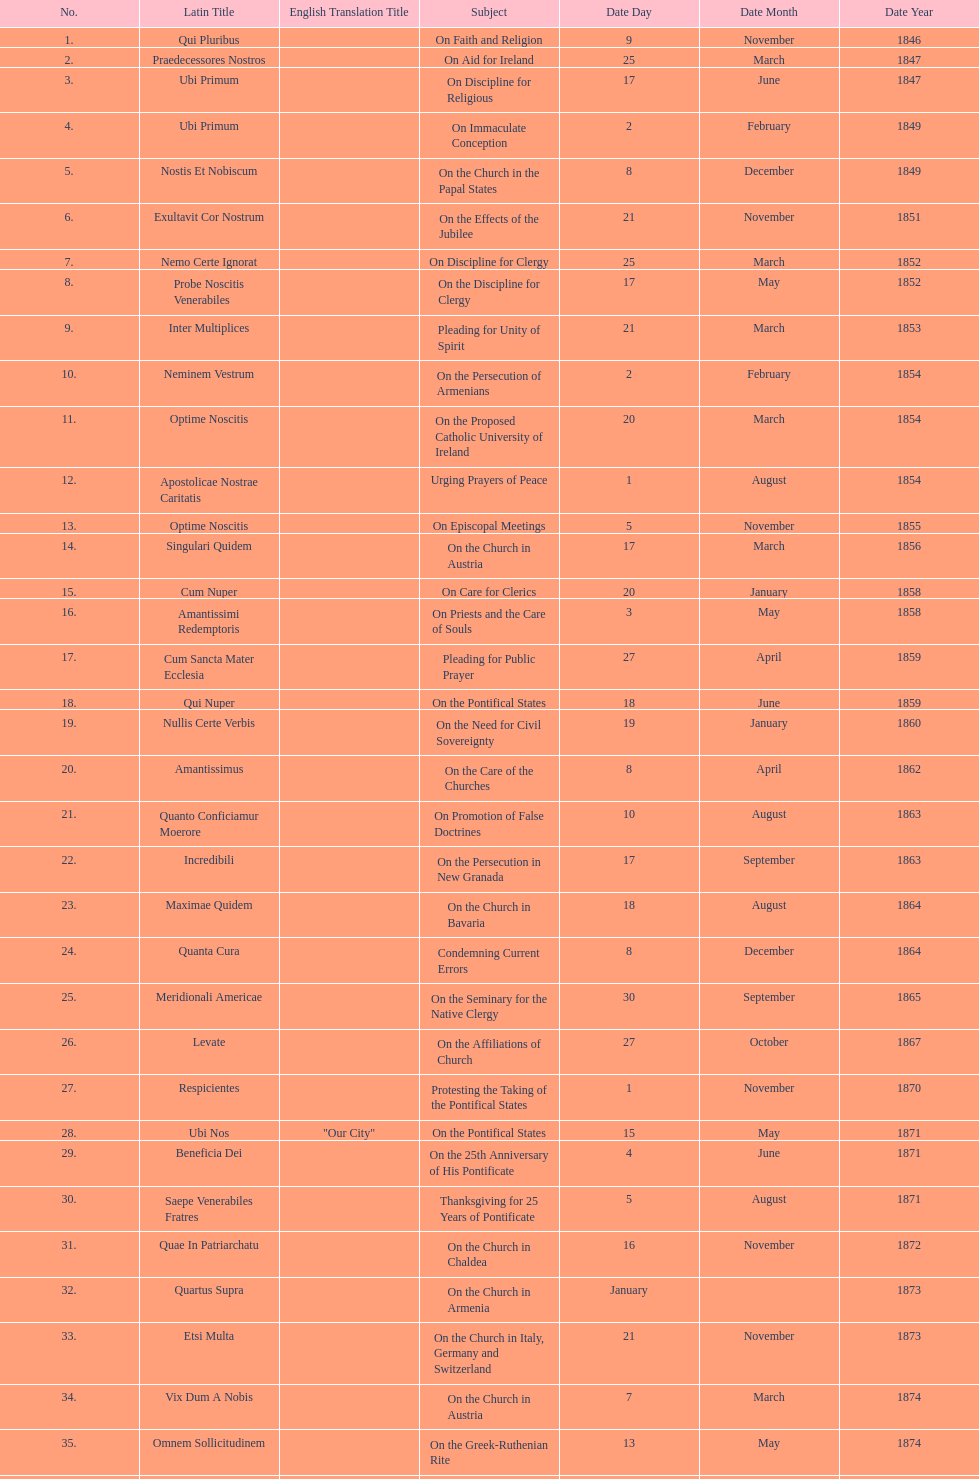Date of the last encyclical whose subject contained the word "pontificate" 5 August 1871. 